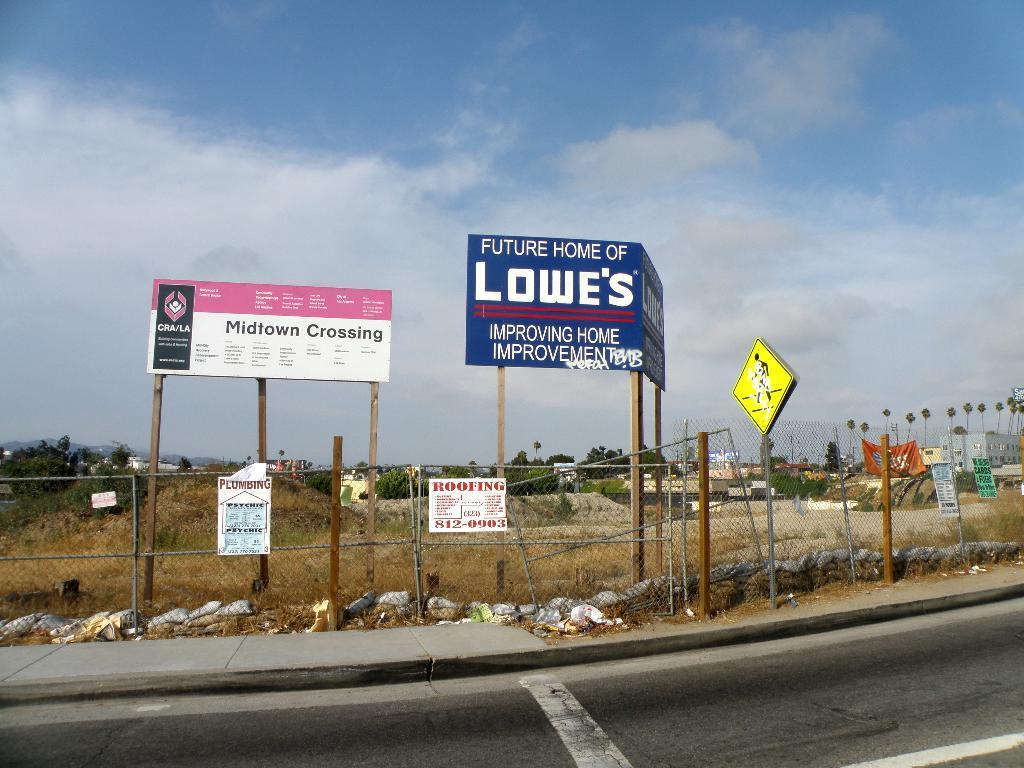Provide a one-sentence caption for the provided image. A blue sign indicates the future home of Lowe's. 